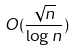<formula> <loc_0><loc_0><loc_500><loc_500>O ( \frac { \sqrt { n } } { \log n } )</formula> 